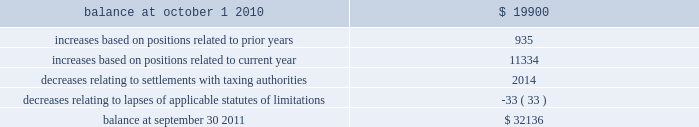Notes to consolidated financial statements 2014 ( continued ) a reconciliation of the beginning and ending amount of gross unrecognized tax benefits is as follows ( in thousands ) : .
The company 2019s major tax jurisdictions as of september 30 , 2011 are the united states , california , iowa , singapore and canada .
For the united states , the company has open tax years dating back to fiscal year 1998 due to the carry forward of tax attributes .
For california and iowa , the company has open tax years dating back to fiscal year 2002 due to the carry forward of tax attributes .
For singapore , the company has open tax years dating back to fiscal year 2011 .
For canada , the company has open tax years dating back to fiscal year 2004 .
During the year ended september 30 , 2011 , the company did not recognize any significant amount of previously unrecognized tax benefits related to the expiration of the statute of limitations .
The company 2019s policy is to recognize accrued interest and penalties , if incurred , on any unrecognized tax benefits as a component of income tax expense .
The company recognized $ 0.5 million of accrued interest or penalties related to unrecognized tax benefits during fiscal year 2011 .
11 .
Stockholders 2019 equity common stock at september 30 , 2011 , the company is authorized to issue 525000000 shares of common stock , par value $ 0.25 per share of which 195407396 shares are issued and 186386197 shares outstanding .
Holders of the company 2019s common stock are entitled to such dividends as may be declared by the company 2019s board of directors out of funds legally available for such purpose .
Dividends may not be paid on common stock unless all accrued dividends on preferred stock , if any , have been paid or declared and set aside .
In the event of the company 2019s liquidation , dissolution or winding up , the holders of common stock will be entitled to share pro rata in the assets remaining after payment to creditors and after payment of the liquidation preference plus any unpaid dividends to holders of any outstanding preferred stock .
Each holder of the company 2019s common stock is entitled to one vote for each such share outstanding in the holder 2019s name .
No holder of common stock is entitled to cumulate votes in voting for directors .
The company 2019s second amended and restated certificate of incorporation provides that , unless otherwise determined by the company 2019s board of directors , no holder of common stock has any preemptive right to purchase or subscribe for any stock of any class which the company may issue or sell .
On august 3 , 2010 , the board of directors approved a stock repurchase program , pursuant to which the company is authorized to repurchase up to $ 200.0 million of the company 2019s common stock from time to time on the open market or in privately negotiated transactions as permitted by securities laws and other legal requirements .
During the fiscal year ended september 30 , 2011 , the company paid approximately $ 70.0 million ( including commissions ) in connection with the repurchase of 2768045 shares of its common stock ( paying an average price of $ 25.30 per share ) .
As of september 30 , 2011 , $ 130.0 million remained available under the existing share repurchase program .
Page 110 skyworks / annual report 2011 .
What is the net change amount of unrecognized tax benefits for the given period? 
Computations: (32136 - 19900)
Answer: 12236.0. 